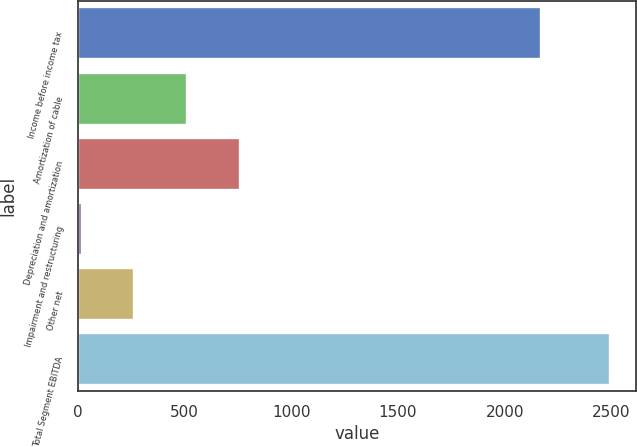Convert chart to OTSL. <chart><loc_0><loc_0><loc_500><loc_500><bar_chart><fcel>Income before income tax<fcel>Amortization of cable<fcel>Depreciation and amortization<fcel>Impairment and restructuring<fcel>Other net<fcel>Total Segment EBITDA<nl><fcel>2170<fcel>511.2<fcel>758.8<fcel>16<fcel>263.6<fcel>2492<nl></chart> 